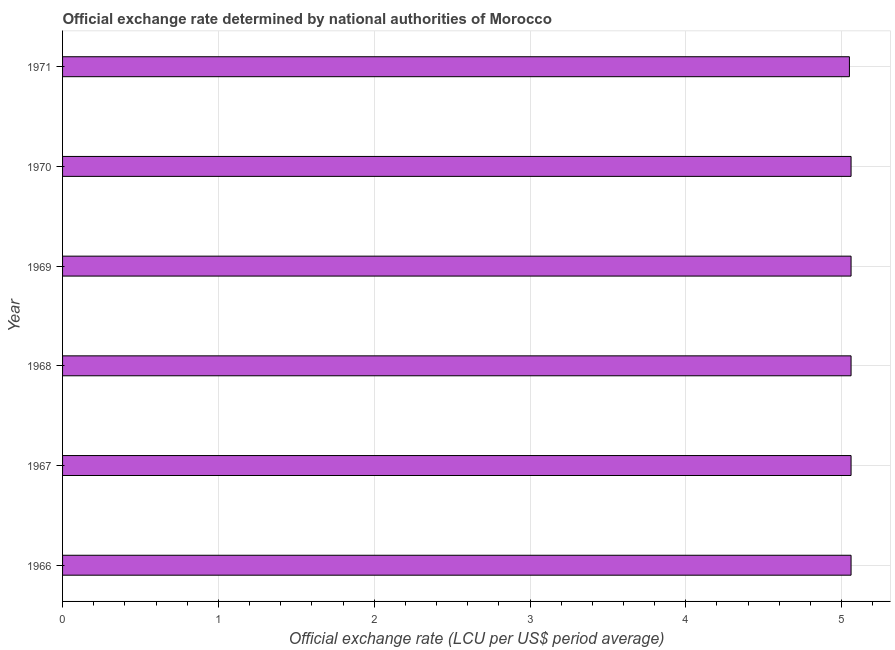What is the title of the graph?
Offer a terse response. Official exchange rate determined by national authorities of Morocco. What is the label or title of the X-axis?
Ensure brevity in your answer.  Official exchange rate (LCU per US$ period average). What is the official exchange rate in 1971?
Ensure brevity in your answer.  5.05. Across all years, what is the maximum official exchange rate?
Keep it short and to the point. 5.06. Across all years, what is the minimum official exchange rate?
Offer a terse response. 5.05. In which year was the official exchange rate maximum?
Your answer should be compact. 1966. What is the sum of the official exchange rate?
Provide a short and direct response. 30.35. What is the average official exchange rate per year?
Offer a very short reply. 5.06. What is the median official exchange rate?
Offer a terse response. 5.06. Do a majority of the years between 1967 and 1968 (inclusive) have official exchange rate greater than 4 ?
Your response must be concise. Yes. What is the ratio of the official exchange rate in 1966 to that in 1971?
Give a very brief answer. 1. Is the official exchange rate in 1969 less than that in 1970?
Give a very brief answer. No. Is the difference between the official exchange rate in 1966 and 1969 greater than the difference between any two years?
Your answer should be compact. No. What is the difference between the highest and the second highest official exchange rate?
Offer a very short reply. 0. Is the sum of the official exchange rate in 1968 and 1969 greater than the maximum official exchange rate across all years?
Offer a very short reply. Yes. What is the difference between the highest and the lowest official exchange rate?
Ensure brevity in your answer.  0.01. In how many years, is the official exchange rate greater than the average official exchange rate taken over all years?
Keep it short and to the point. 5. How many bars are there?
Offer a very short reply. 6. How many years are there in the graph?
Ensure brevity in your answer.  6. What is the difference between two consecutive major ticks on the X-axis?
Make the answer very short. 1. What is the Official exchange rate (LCU per US$ period average) of 1966?
Provide a succinct answer. 5.06. What is the Official exchange rate (LCU per US$ period average) of 1967?
Give a very brief answer. 5.06. What is the Official exchange rate (LCU per US$ period average) of 1968?
Provide a short and direct response. 5.06. What is the Official exchange rate (LCU per US$ period average) of 1969?
Your answer should be very brief. 5.06. What is the Official exchange rate (LCU per US$ period average) in 1970?
Your answer should be very brief. 5.06. What is the Official exchange rate (LCU per US$ period average) in 1971?
Provide a short and direct response. 5.05. What is the difference between the Official exchange rate (LCU per US$ period average) in 1966 and 1970?
Keep it short and to the point. 0. What is the difference between the Official exchange rate (LCU per US$ period average) in 1966 and 1971?
Ensure brevity in your answer.  0.01. What is the difference between the Official exchange rate (LCU per US$ period average) in 1967 and 1968?
Keep it short and to the point. 0. What is the difference between the Official exchange rate (LCU per US$ period average) in 1967 and 1969?
Offer a terse response. 0. What is the difference between the Official exchange rate (LCU per US$ period average) in 1967 and 1970?
Ensure brevity in your answer.  0. What is the difference between the Official exchange rate (LCU per US$ period average) in 1967 and 1971?
Your answer should be compact. 0.01. What is the difference between the Official exchange rate (LCU per US$ period average) in 1968 and 1971?
Your answer should be compact. 0.01. What is the difference between the Official exchange rate (LCU per US$ period average) in 1969 and 1970?
Make the answer very short. 0. What is the difference between the Official exchange rate (LCU per US$ period average) in 1969 and 1971?
Offer a very short reply. 0.01. What is the difference between the Official exchange rate (LCU per US$ period average) in 1970 and 1971?
Make the answer very short. 0.01. What is the ratio of the Official exchange rate (LCU per US$ period average) in 1966 to that in 1969?
Ensure brevity in your answer.  1. What is the ratio of the Official exchange rate (LCU per US$ period average) in 1966 to that in 1970?
Ensure brevity in your answer.  1. What is the ratio of the Official exchange rate (LCU per US$ period average) in 1966 to that in 1971?
Provide a short and direct response. 1. What is the ratio of the Official exchange rate (LCU per US$ period average) in 1967 to that in 1968?
Make the answer very short. 1. What is the ratio of the Official exchange rate (LCU per US$ period average) in 1967 to that in 1970?
Make the answer very short. 1. What is the ratio of the Official exchange rate (LCU per US$ period average) in 1969 to that in 1970?
Keep it short and to the point. 1. What is the ratio of the Official exchange rate (LCU per US$ period average) in 1969 to that in 1971?
Your answer should be very brief. 1. 